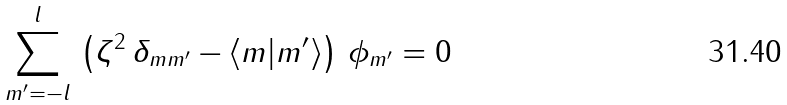<formula> <loc_0><loc_0><loc_500><loc_500>\sum _ { m ^ { \prime } = - l } ^ { l } \, \left ( \zeta ^ { 2 } \, \delta _ { m m ^ { \prime } } - \langle m | m ^ { \prime } \rangle \right ) \, \phi _ { m ^ { \prime } } = 0</formula> 